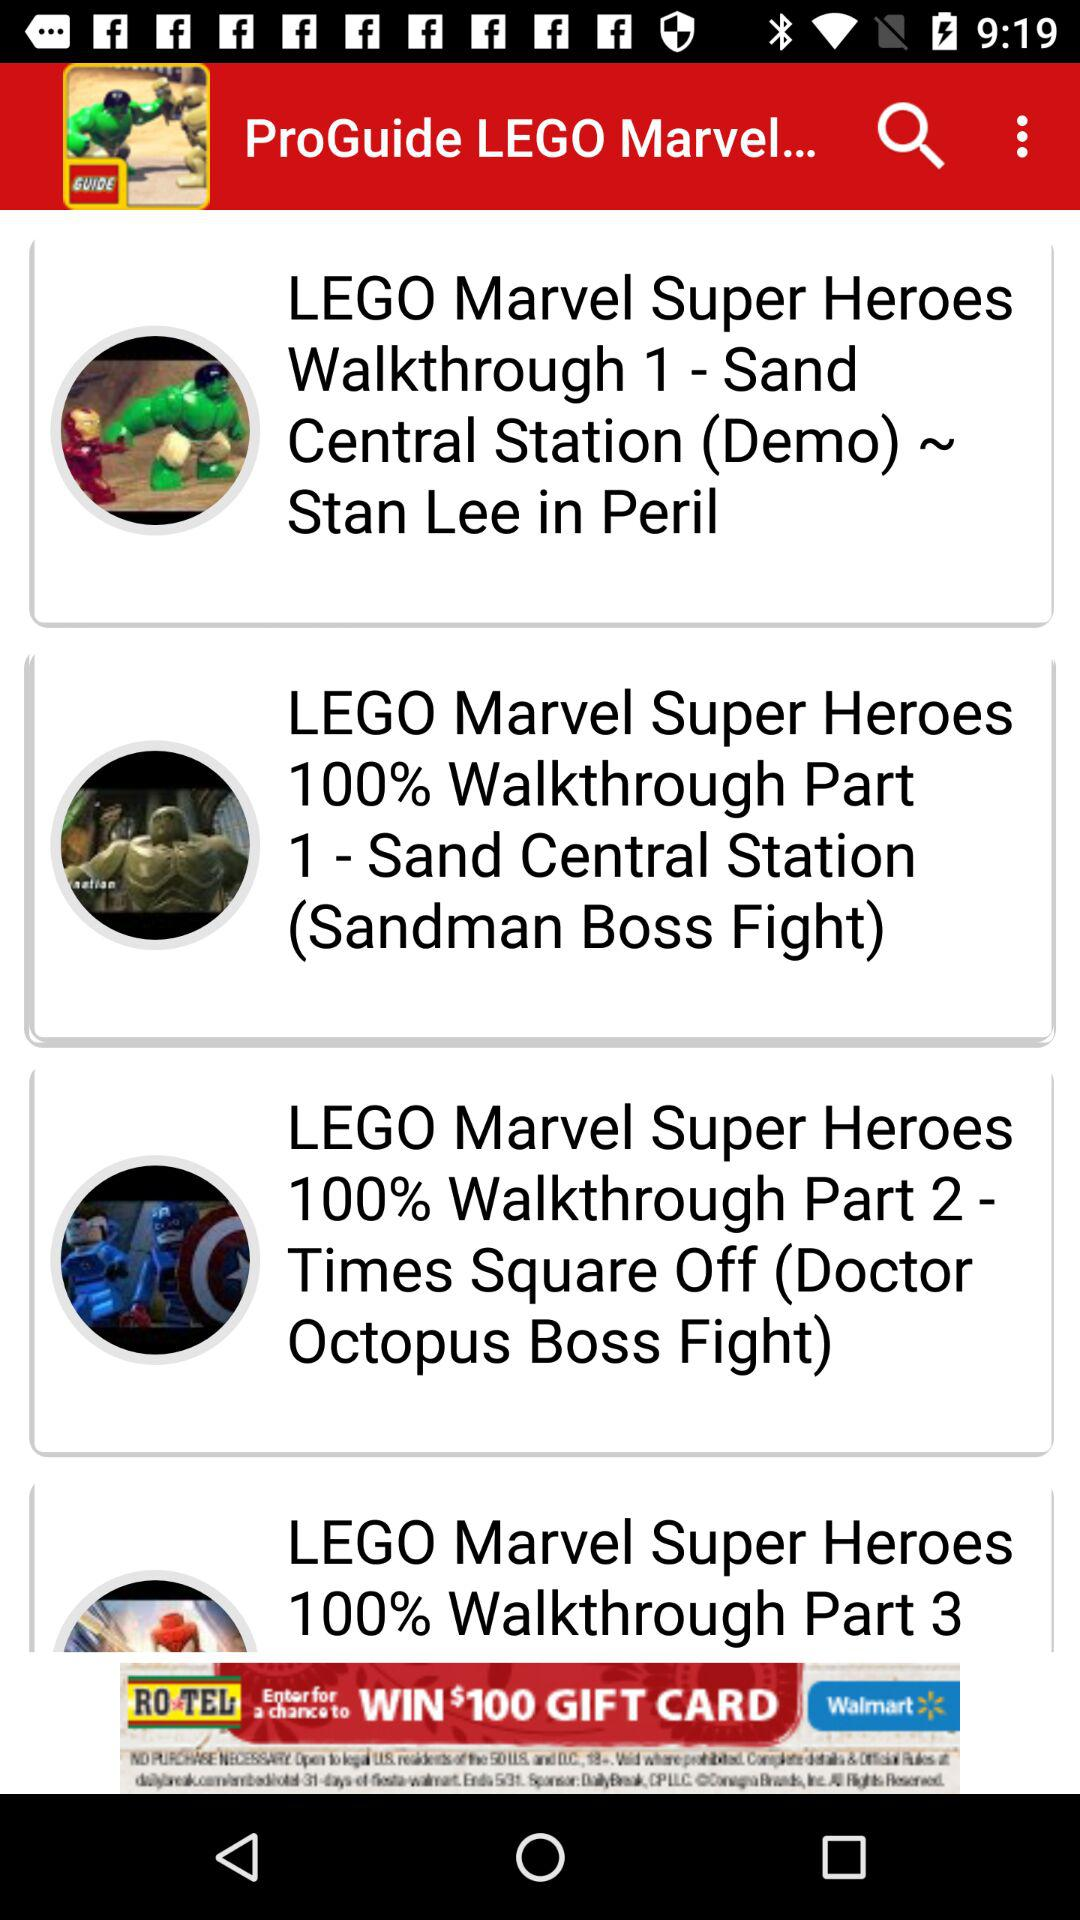What is the name of the application? The name of the application is "ProGuide LEGO Marvel Superhero". 